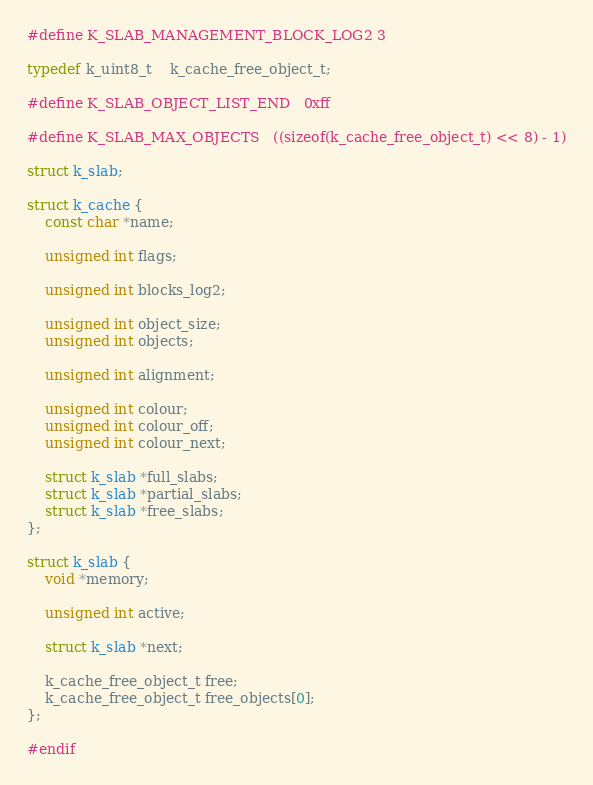<code> <loc_0><loc_0><loc_500><loc_500><_C_>#define K_SLAB_MANAGEMENT_BLOCK_LOG2	3

typedef k_uint8_t	k_cache_free_object_t;

#define K_SLAB_OBJECT_LIST_END	0xff

#define K_SLAB_MAX_OBJECTS	((sizeof(k_cache_free_object_t) << 8) - 1)

struct k_slab;

struct k_cache {
	const char *name;

	unsigned int flags;

	unsigned int blocks_log2;

	unsigned int object_size;
	unsigned int objects;

	unsigned int alignment;

	unsigned int colour;
	unsigned int colour_off;
	unsigned int colour_next;

	struct k_slab *full_slabs;
	struct k_slab *partial_slabs;
	struct k_slab *free_slabs;
};

struct k_slab {
	void *memory;

	unsigned int active;

	struct k_slab *next;

	k_cache_free_object_t free;
	k_cache_free_object_t free_objects[0];
};

#endif

</code> 